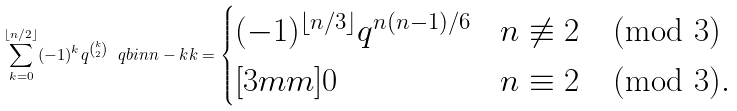<formula> <loc_0><loc_0><loc_500><loc_500>\sum _ { k = 0 } ^ { \lfloor n / 2 \rfloor } ( - 1 ) ^ { k } q ^ { \binom { k } { 2 } } \ q b i n { n - k } { k } = \begin{cases} ( - 1 ) ^ { \lfloor n / 3 \rfloor } q ^ { n ( n - 1 ) / 6 } & n \not \equiv 2 \pmod { 3 } \\ [ 3 m m ] 0 & n \equiv 2 \pmod { 3 } . \end{cases}</formula> 